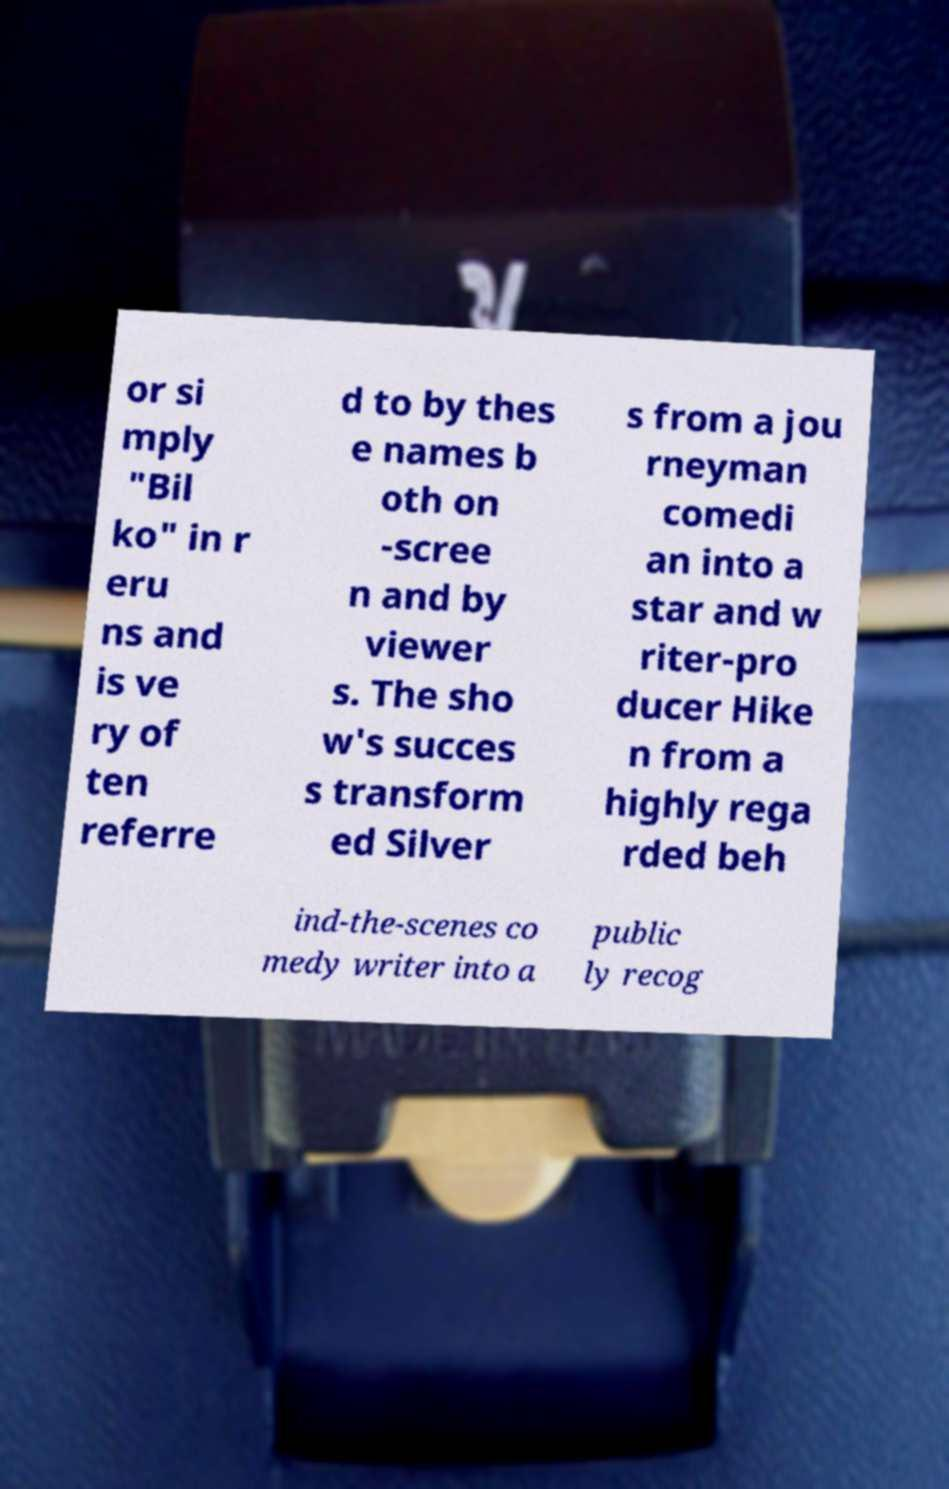Can you read and provide the text displayed in the image?This photo seems to have some interesting text. Can you extract and type it out for me? or si mply "Bil ko" in r eru ns and is ve ry of ten referre d to by thes e names b oth on -scree n and by viewer s. The sho w's succes s transform ed Silver s from a jou rneyman comedi an into a star and w riter-pro ducer Hike n from a highly rega rded beh ind-the-scenes co medy writer into a public ly recog 